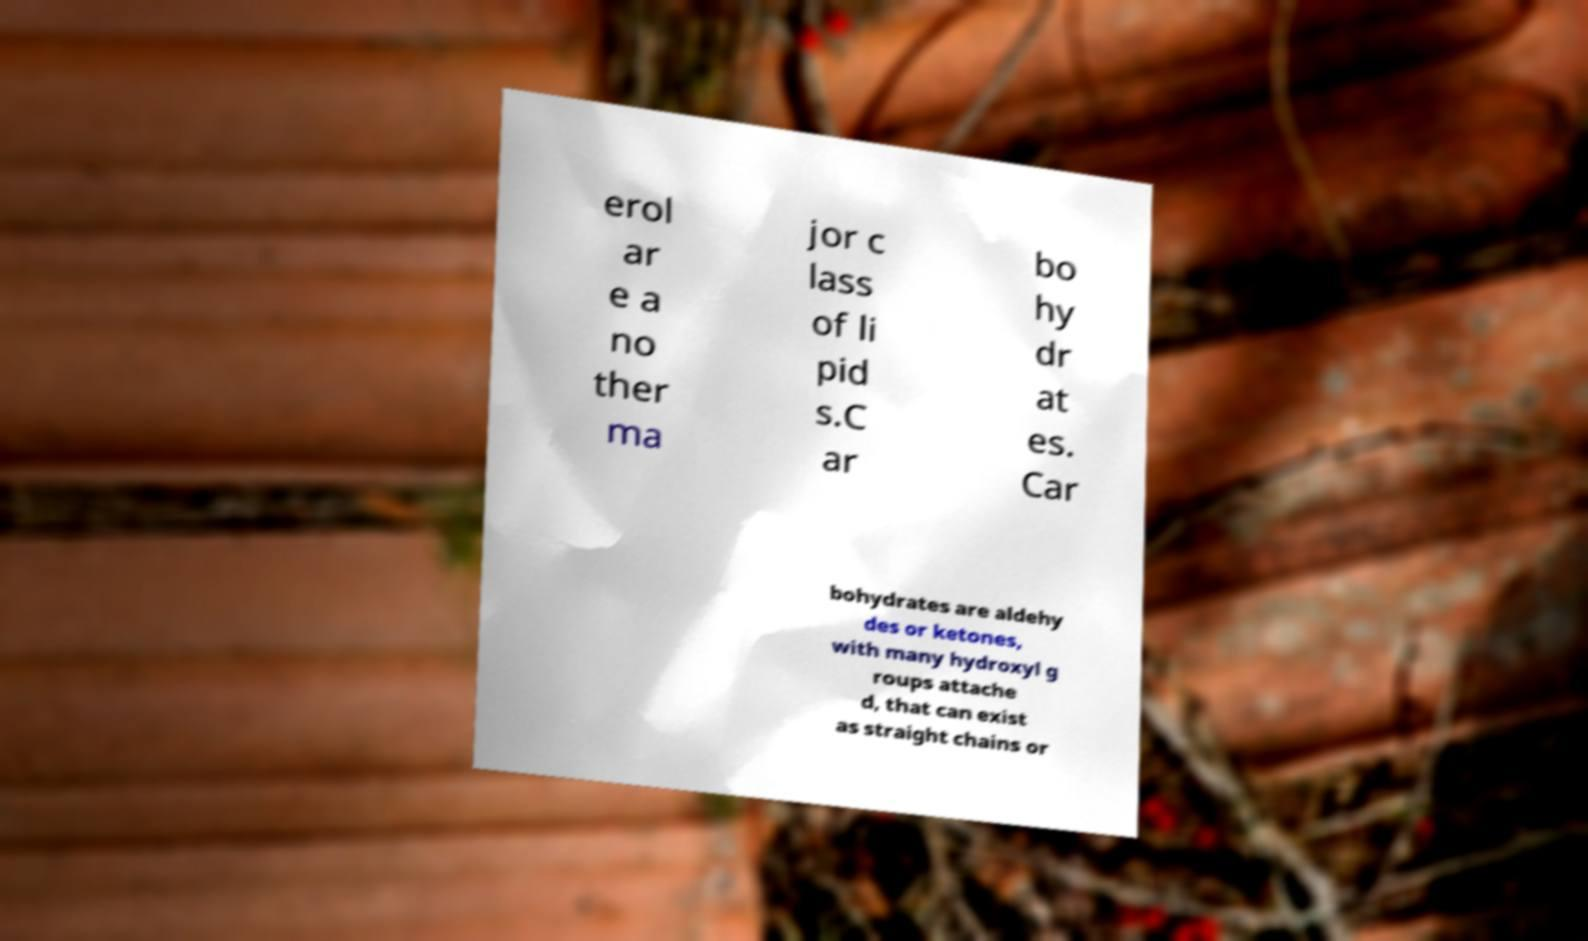Can you read and provide the text displayed in the image?This photo seems to have some interesting text. Can you extract and type it out for me? erol ar e a no ther ma jor c lass of li pid s.C ar bo hy dr at es. Car bohydrates are aldehy des or ketones, with many hydroxyl g roups attache d, that can exist as straight chains or 